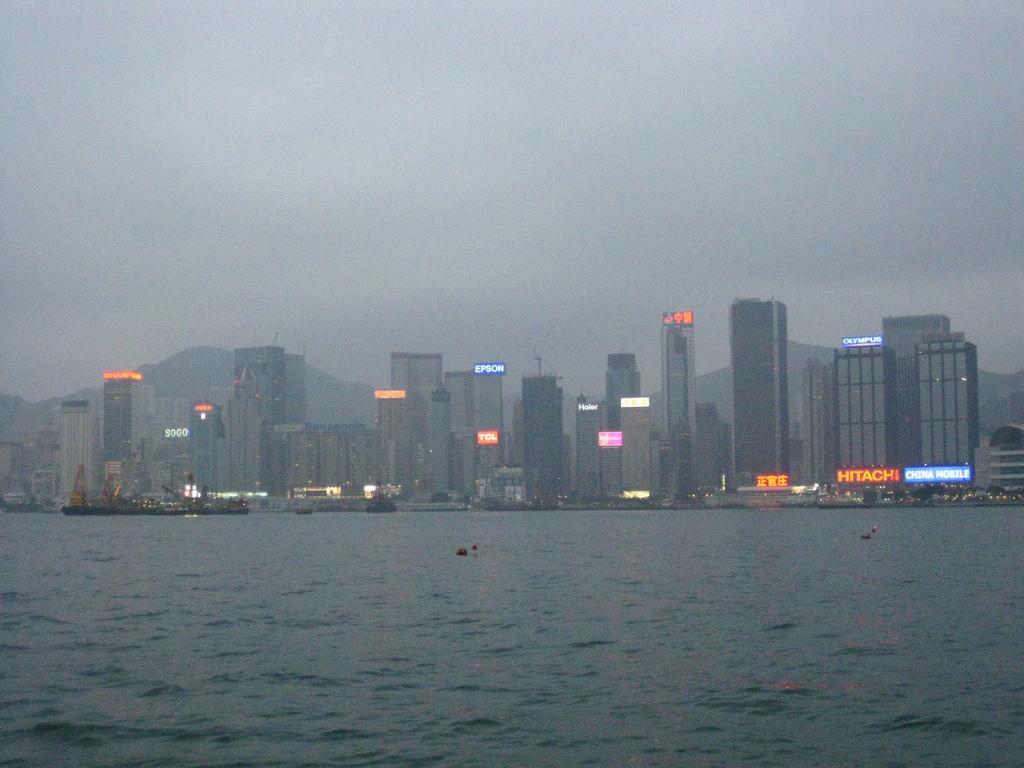Could you give a brief overview of what you see in this image? In this game there are buildings and we can see boards. At the bottom there is water and we can see boats on the water. In the background there is sky and we can see hills. 